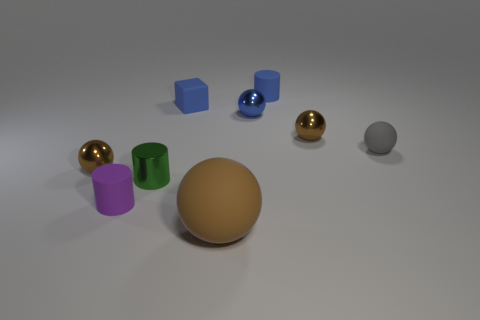What materials do the objects in the image appear to be made of? The objects in the image seem to have different materials. The spheres have a shiny appearance suggesting metallic properties, the cubes appear matte and could be plastic or wooden, and the cylindrical shapes look like they might be made of a matte plastic or rubber due to their soft sheen. 